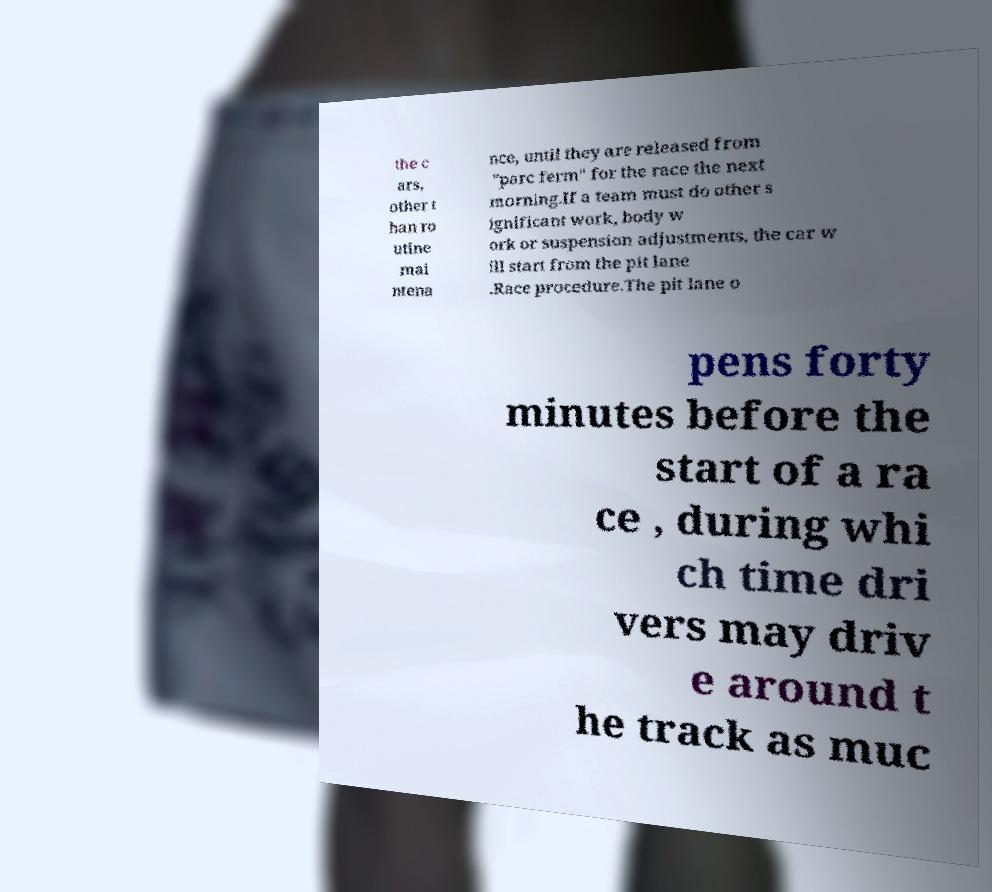Could you assist in decoding the text presented in this image and type it out clearly? the c ars, other t han ro utine mai ntena nce, until they are released from "parc ferm" for the race the next morning.If a team must do other s ignificant work, body w ork or suspension adjustments, the car w ill start from the pit lane .Race procedure.The pit lane o pens forty minutes before the start of a ra ce , during whi ch time dri vers may driv e around t he track as muc 